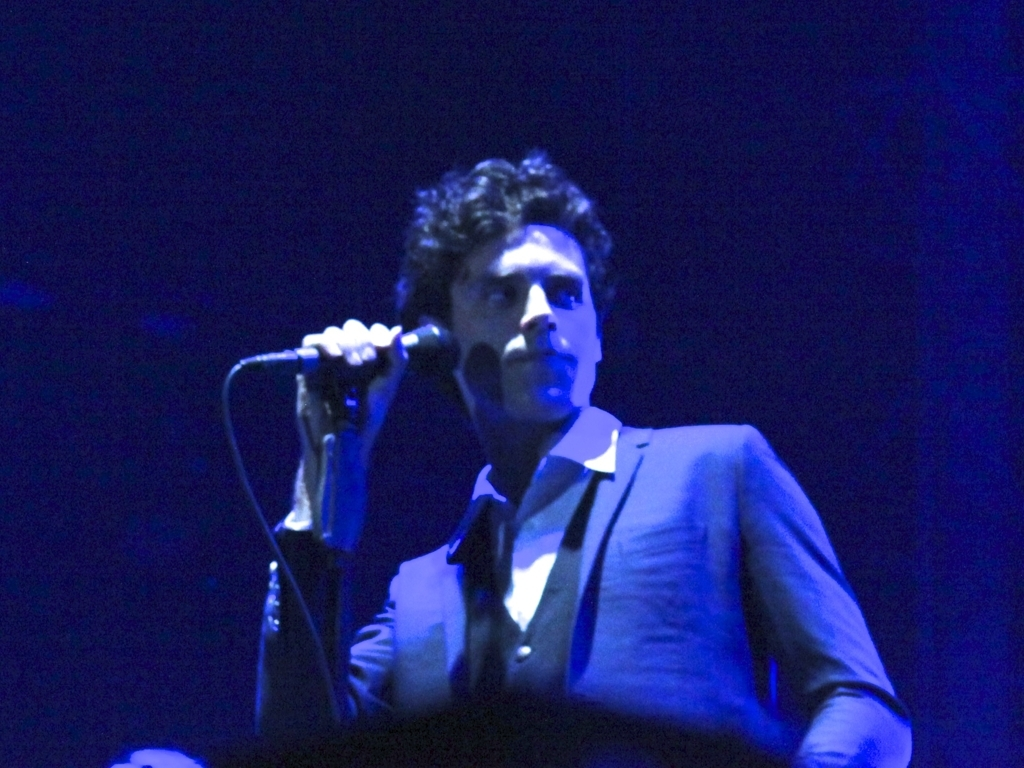What kind of event might this be? Based on the image, this appears to be a live performance, possibly a concert or a theatrical event, where a person is on stage with a microphone. What emotions does the lighting in the image evoke? The blue hues and shadows cast by the lighting create a sense of intrigue and intimacy, often evoking feelings of calmness or reflectiveness suitable for live music or dramatic performances. 